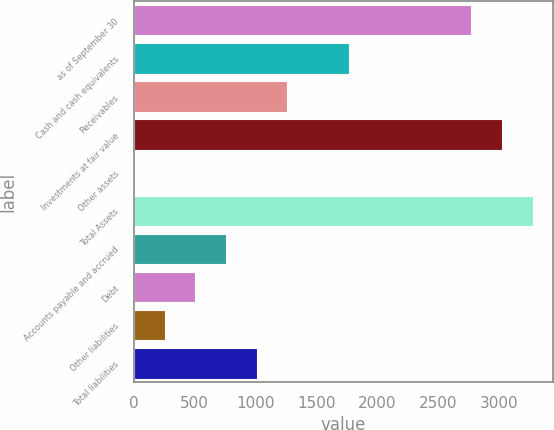<chart> <loc_0><loc_0><loc_500><loc_500><bar_chart><fcel>as of September 30<fcel>Cash and cash equivalents<fcel>Receivables<fcel>Investments at fair value<fcel>Other assets<fcel>Total Assets<fcel>Accounts payable and accrued<fcel>Debt<fcel>Other liabilities<fcel>Total liabilities<nl><fcel>2776.74<fcel>1767.38<fcel>1262.7<fcel>3029.08<fcel>1<fcel>3281.42<fcel>758.02<fcel>505.68<fcel>253.34<fcel>1010.36<nl></chart> 